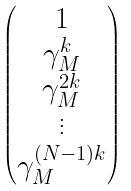Convert formula to latex. <formula><loc_0><loc_0><loc_500><loc_500>\begin{pmatrix} 1 \\ \gamma _ { M } ^ { k } \\ \gamma _ { M } ^ { 2 k } \\ \vdots \\ \gamma _ { M } ^ { ( N - 1 ) k } \end{pmatrix}</formula> 